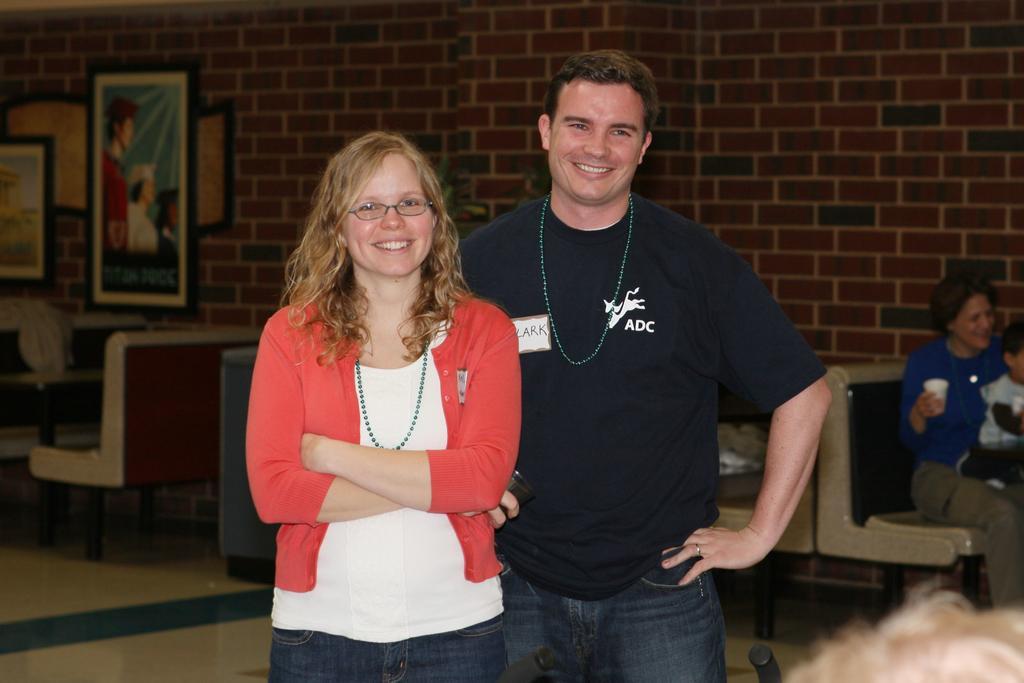In one or two sentences, can you explain what this image depicts? In the middle of the picture I can see two persons are standing and smiling by looking at the straight. In the background of the image I can see sofas. On the right side of the image I can see one lady with small children. 